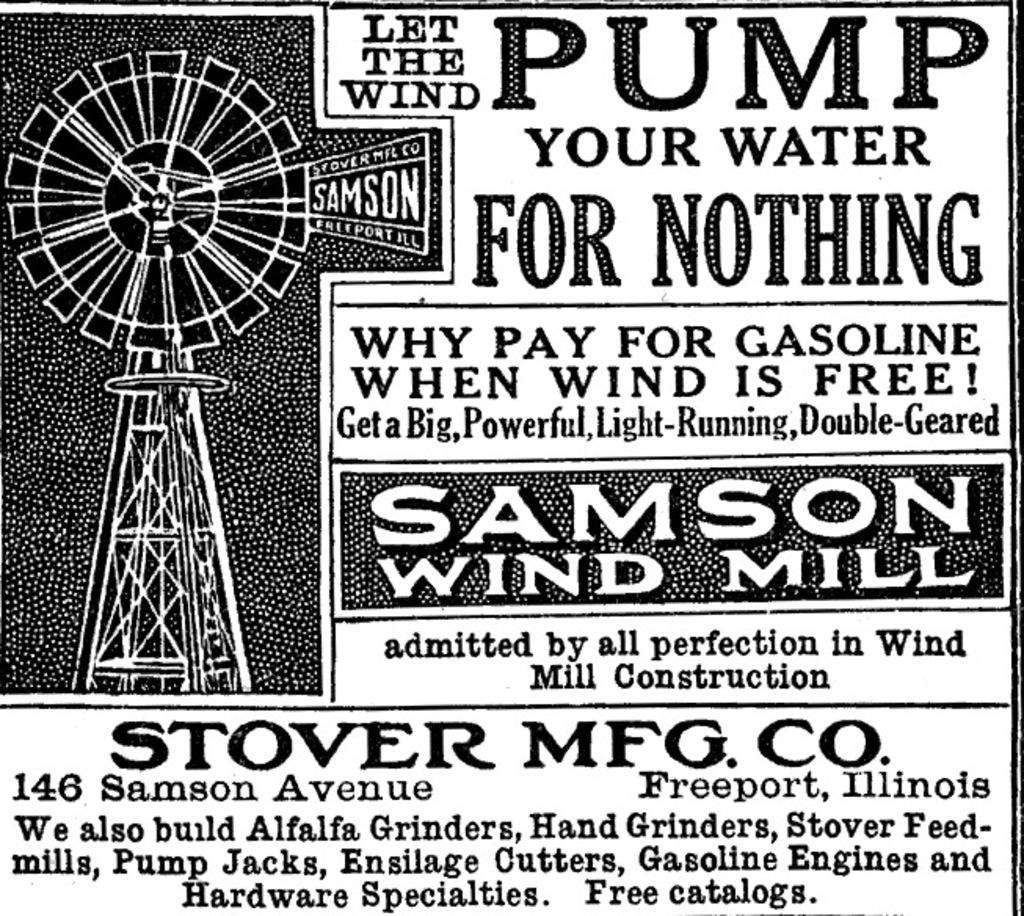<image>
Offer a succinct explanation of the picture presented. An advertisement for Samson Wind Mill in Illinois. 